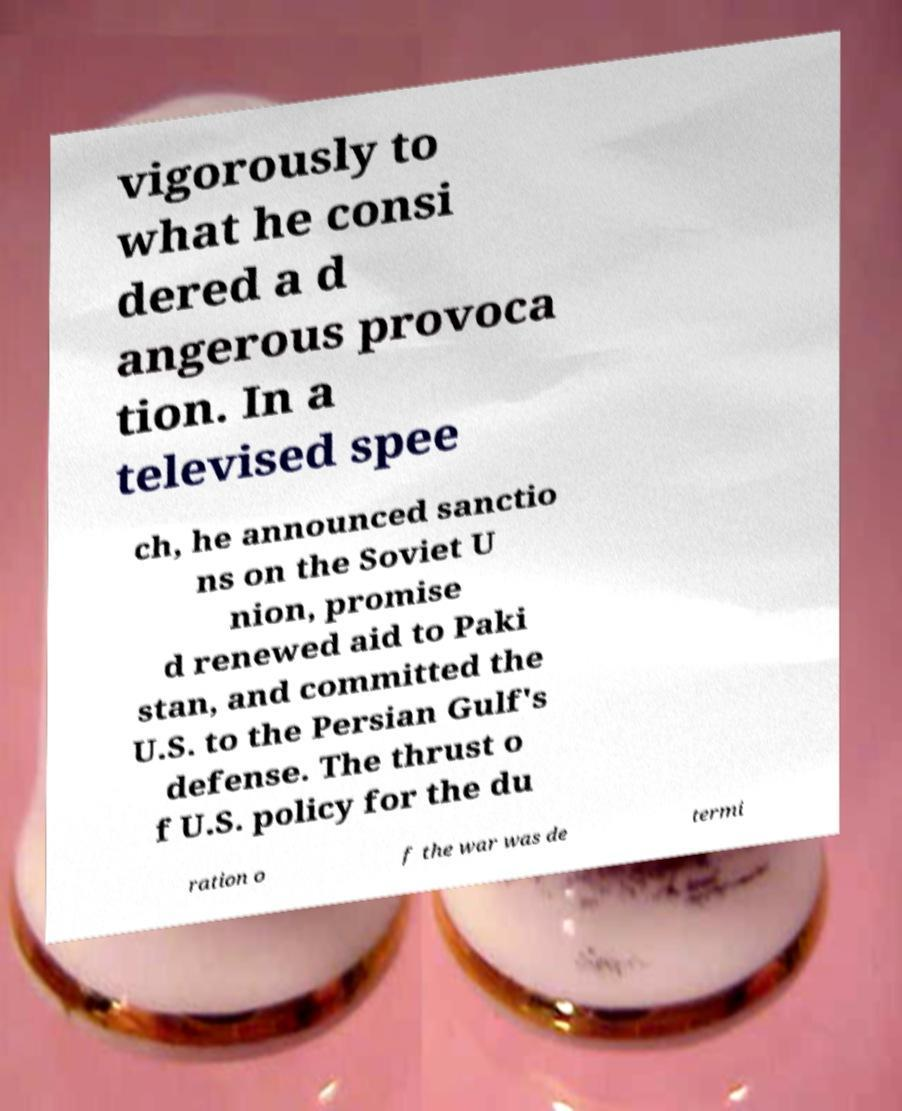Can you read and provide the text displayed in the image?This photo seems to have some interesting text. Can you extract and type it out for me? vigorously to what he consi dered a d angerous provoca tion. In a televised spee ch, he announced sanctio ns on the Soviet U nion, promise d renewed aid to Paki stan, and committed the U.S. to the Persian Gulf's defense. The thrust o f U.S. policy for the du ration o f the war was de termi 